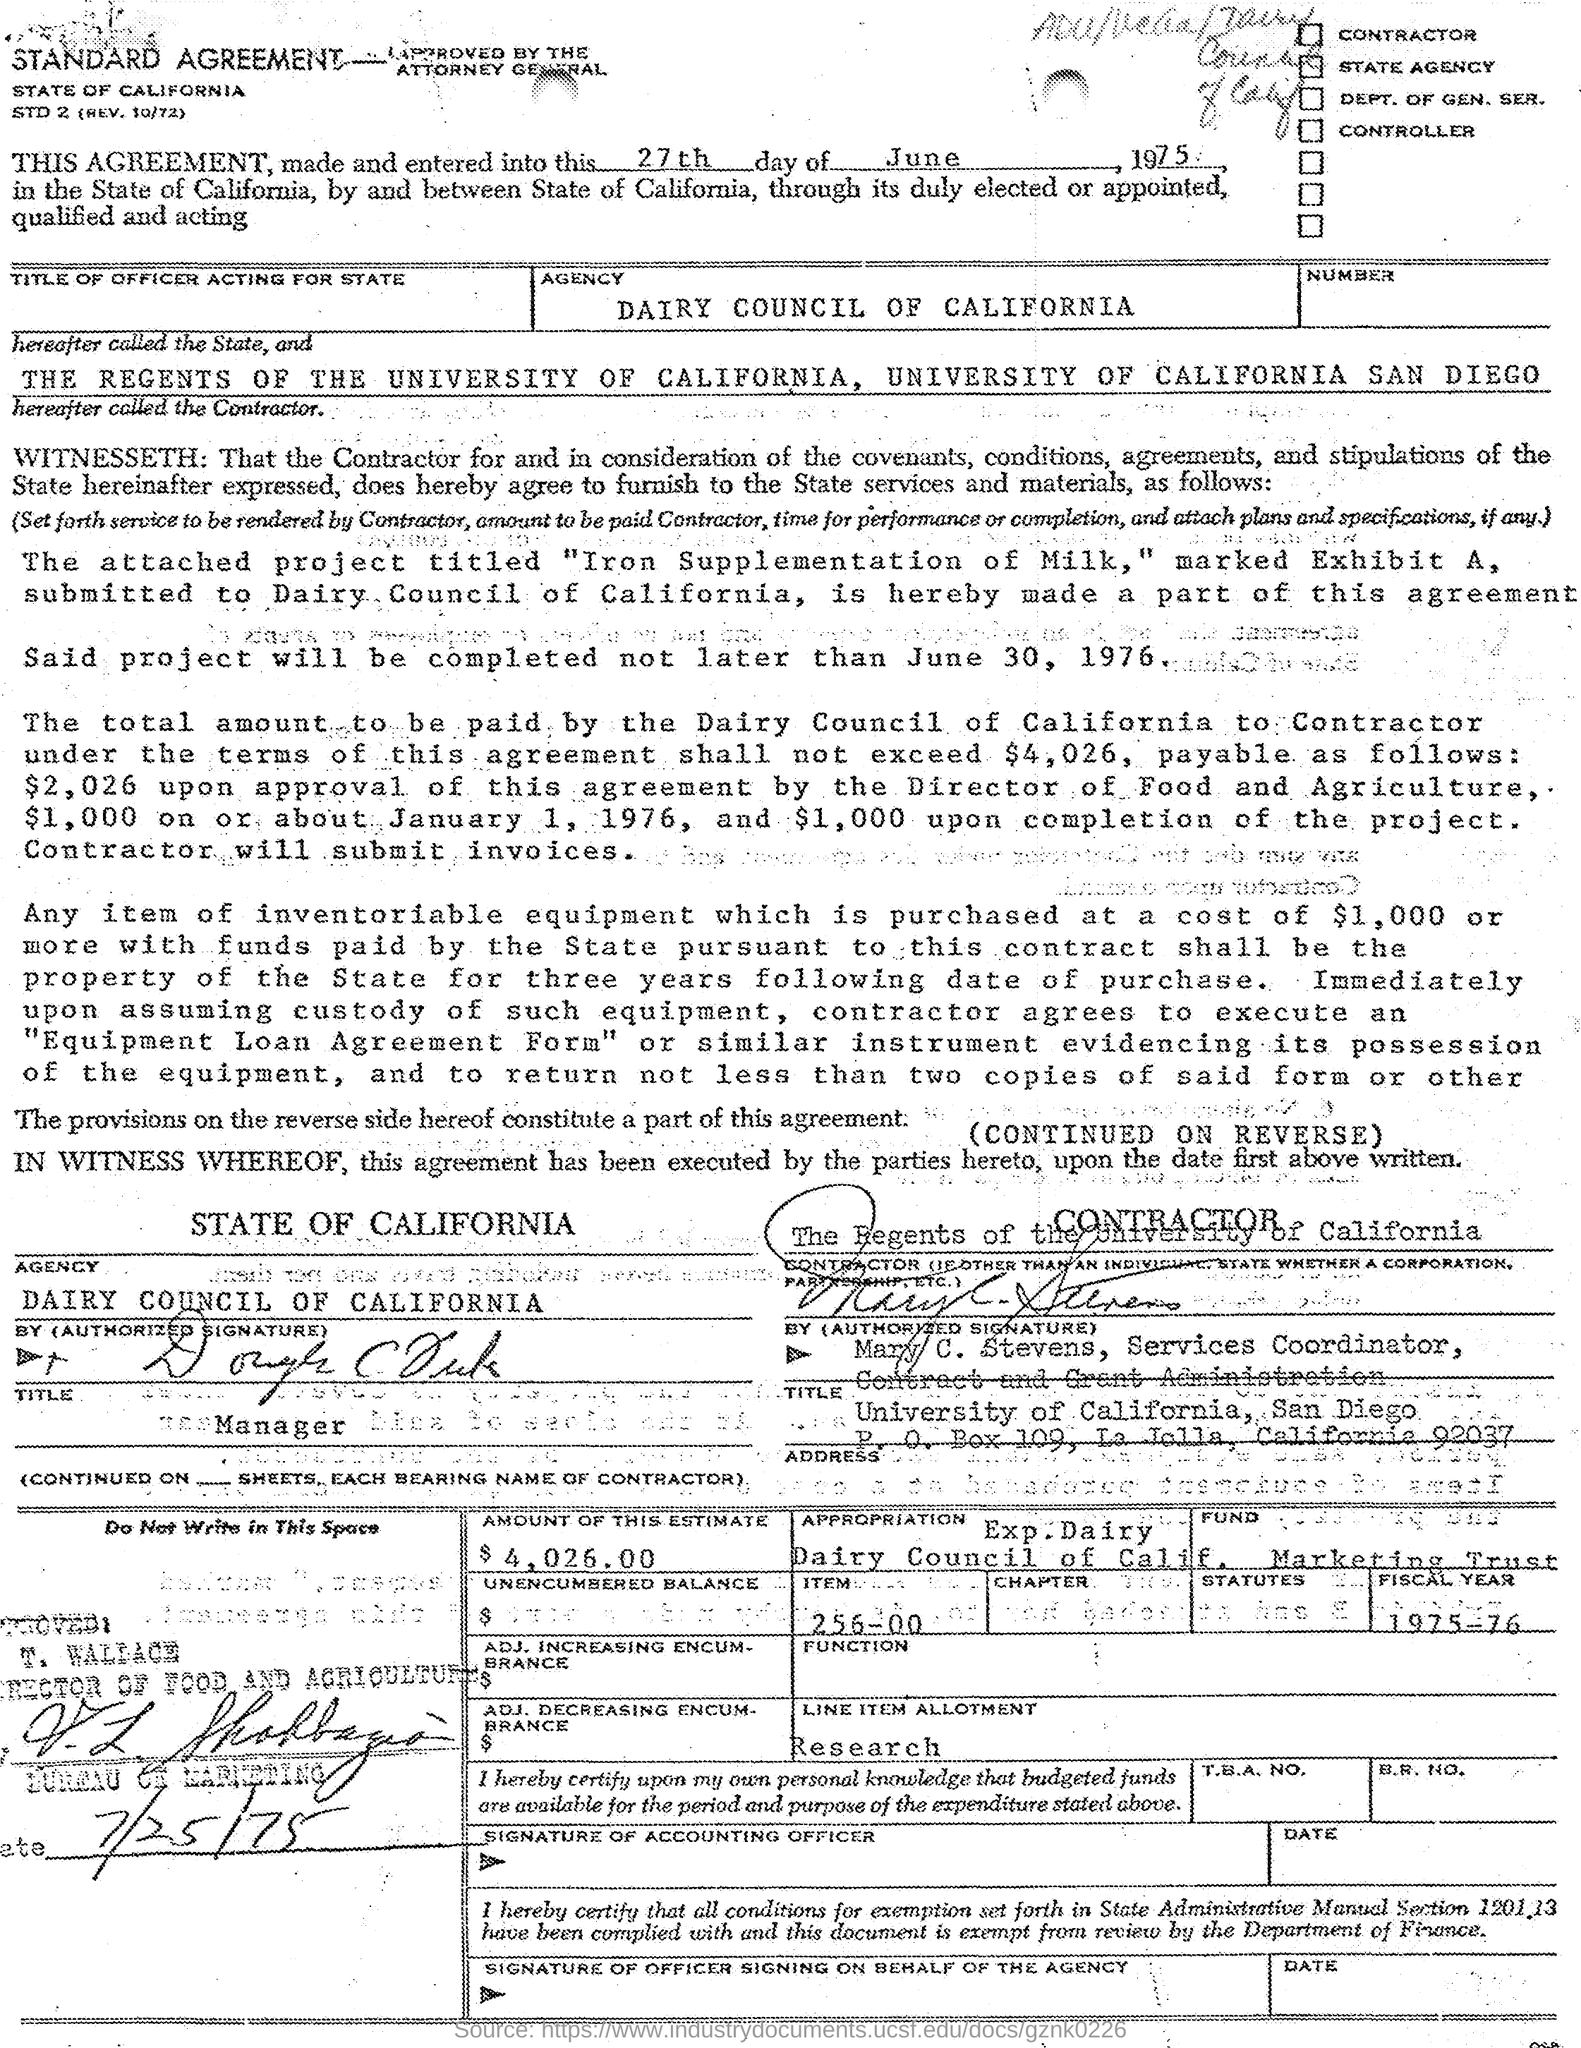Specify some key components in this picture. The project is expected to be completed by June 30, 1976. The service coordinator is Mary C. Stevens, and the contract and grand administration are her responsibilities. The individual known as T. Wallace is the director of Food and Agriculture. The fiscal year mentioned is 1975-76. The Dairy Council of California is the name of an agency. 